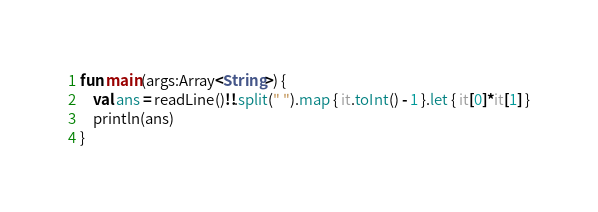Convert code to text. <code><loc_0><loc_0><loc_500><loc_500><_Kotlin_>fun main(args:Array<String>) {
    val ans = readLine()!!.split(" ").map { it.toInt() - 1 }.let { it[0]*it[1] }
    println(ans)
}
</code> 